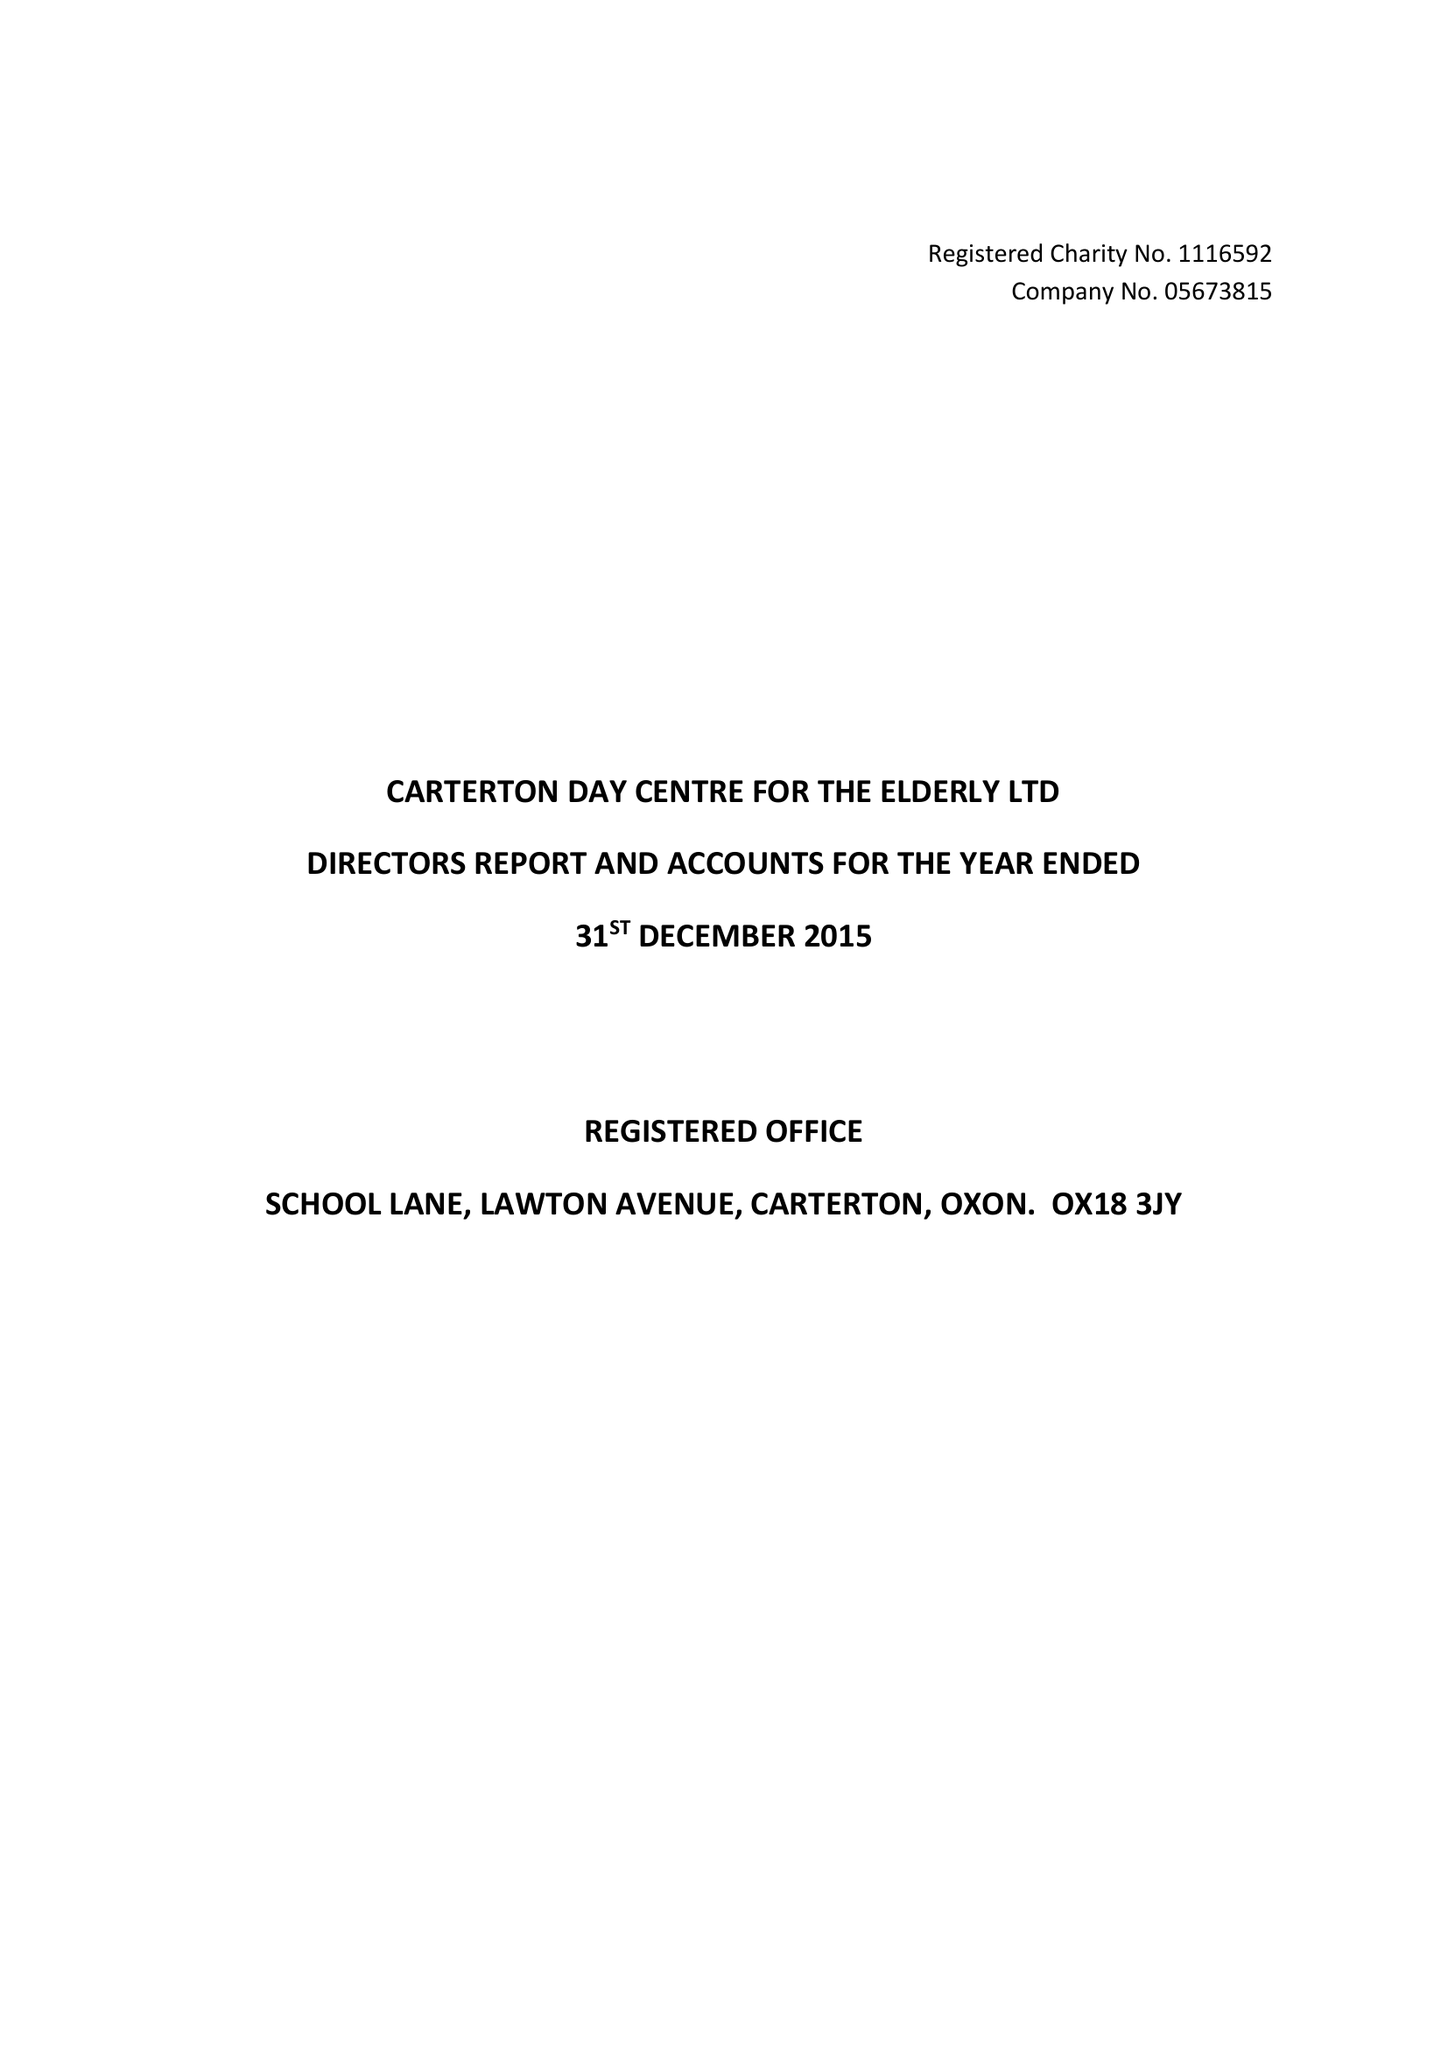What is the value for the address__post_town?
Answer the question using a single word or phrase. CARTERTON 